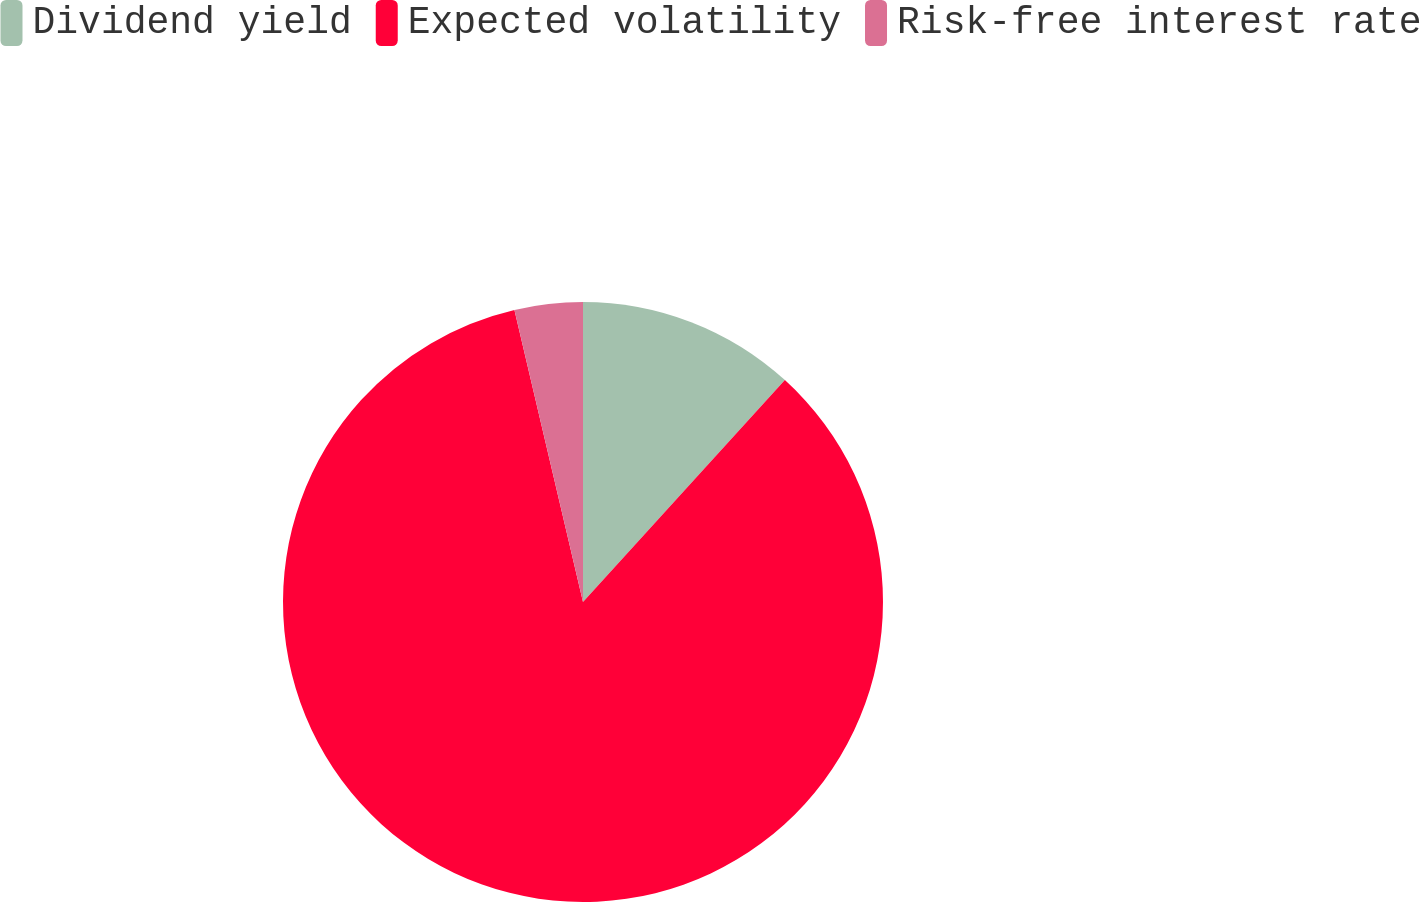Convert chart to OTSL. <chart><loc_0><loc_0><loc_500><loc_500><pie_chart><fcel>Dividend yield<fcel>Expected volatility<fcel>Risk-free interest rate<nl><fcel>11.75%<fcel>84.58%<fcel>3.67%<nl></chart> 